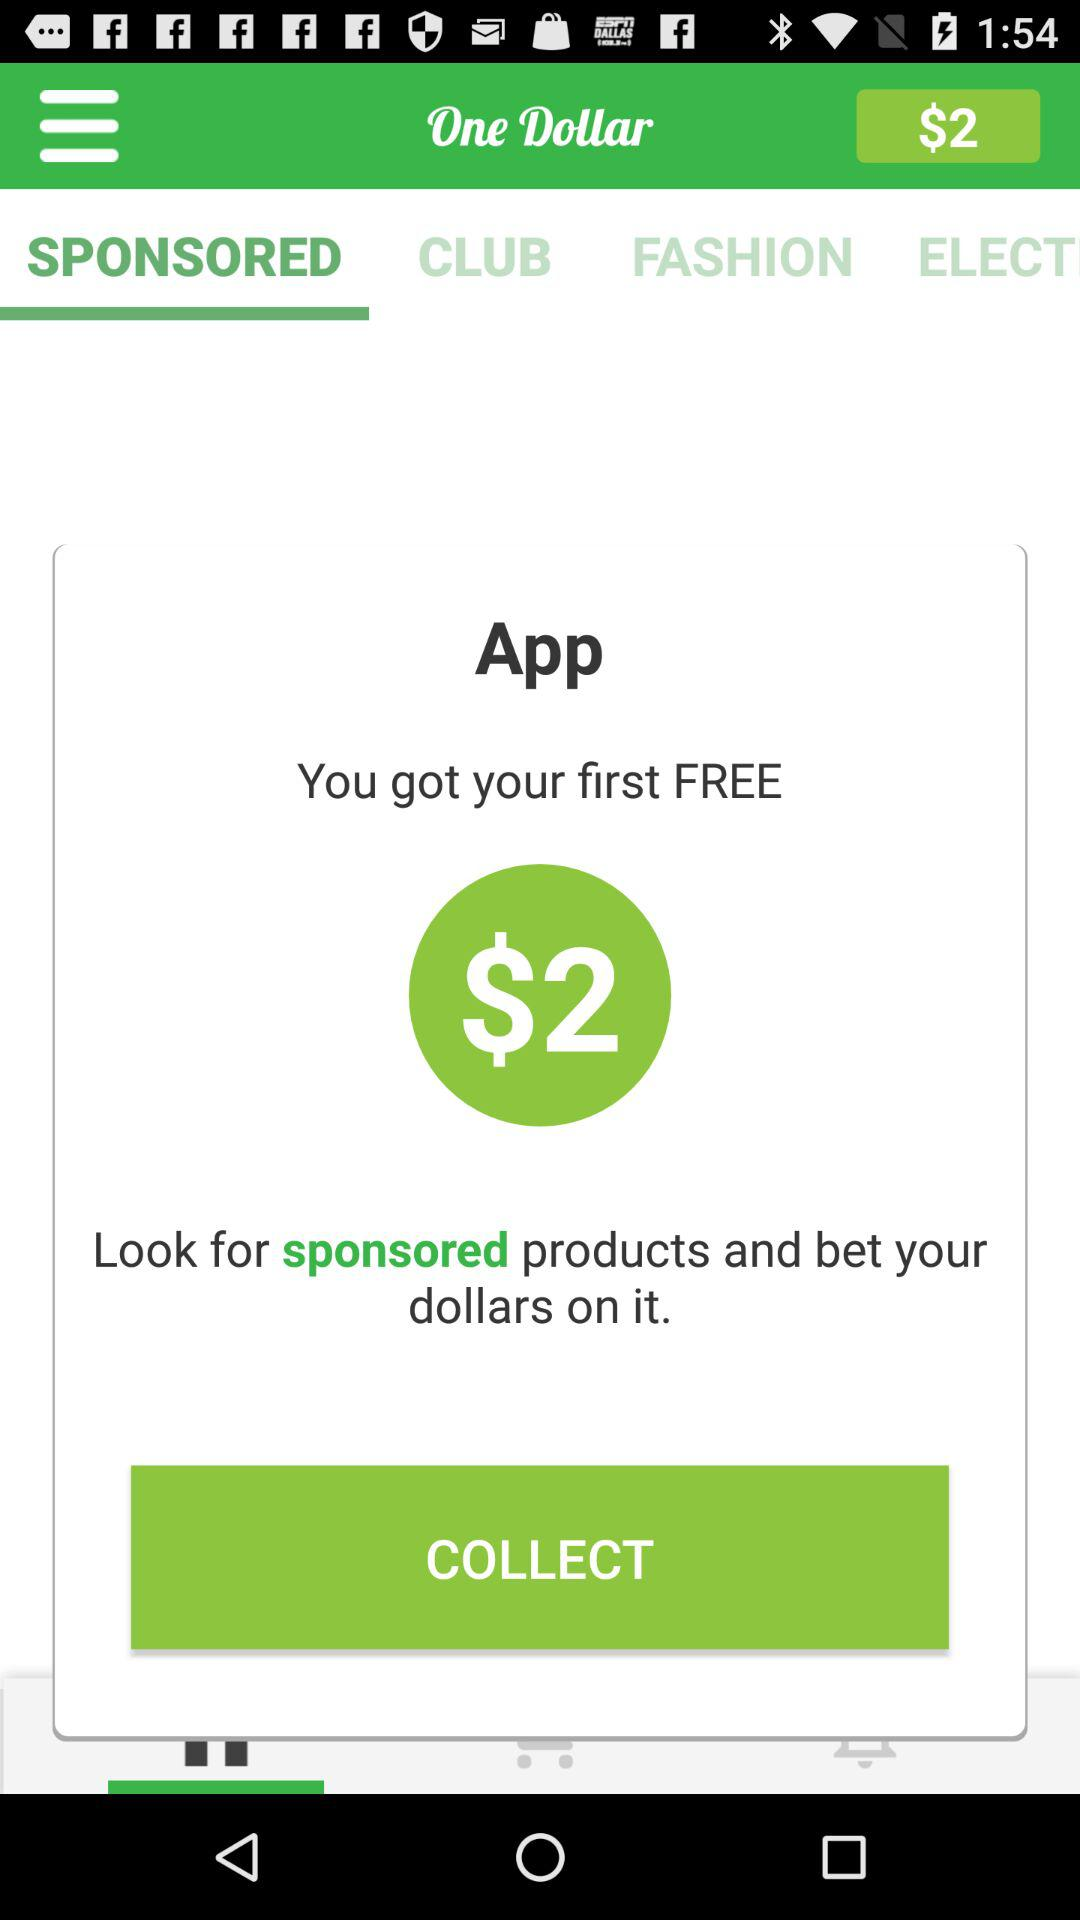Which tab is selected? The selected tab is "SPONSORED". 